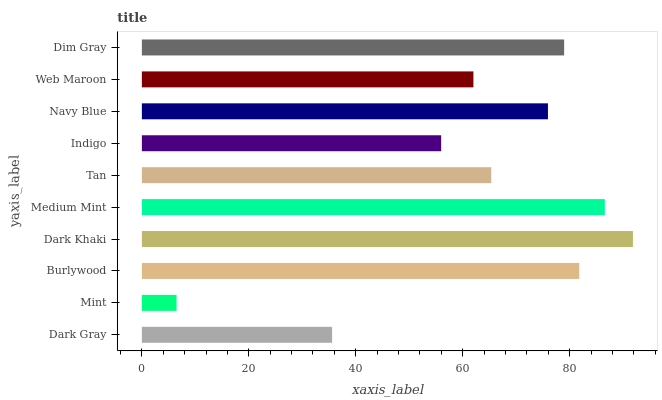Is Mint the minimum?
Answer yes or no. Yes. Is Dark Khaki the maximum?
Answer yes or no. Yes. Is Burlywood the minimum?
Answer yes or no. No. Is Burlywood the maximum?
Answer yes or no. No. Is Burlywood greater than Mint?
Answer yes or no. Yes. Is Mint less than Burlywood?
Answer yes or no. Yes. Is Mint greater than Burlywood?
Answer yes or no. No. Is Burlywood less than Mint?
Answer yes or no. No. Is Navy Blue the high median?
Answer yes or no. Yes. Is Tan the low median?
Answer yes or no. Yes. Is Burlywood the high median?
Answer yes or no. No. Is Indigo the low median?
Answer yes or no. No. 